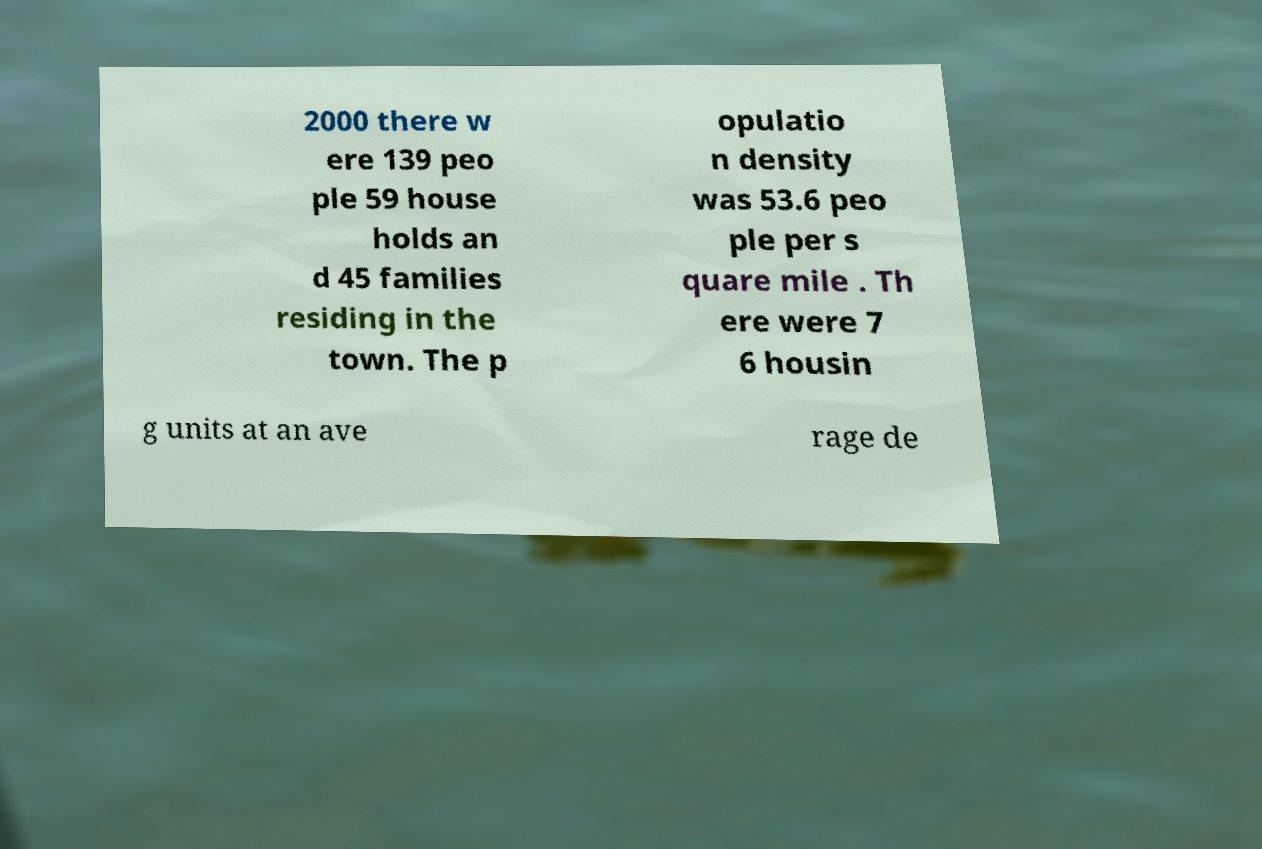Could you extract and type out the text from this image? 2000 there w ere 139 peo ple 59 house holds an d 45 families residing in the town. The p opulatio n density was 53.6 peo ple per s quare mile . Th ere were 7 6 housin g units at an ave rage de 